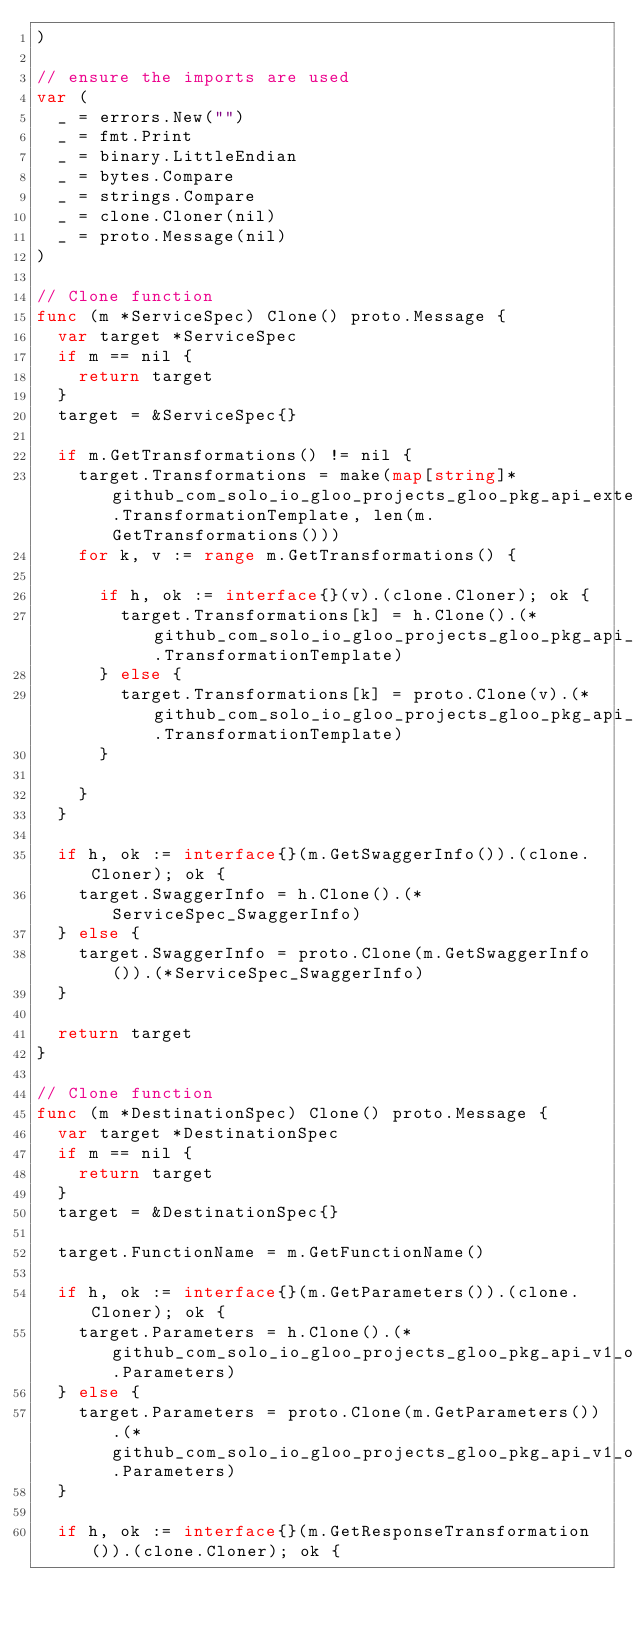<code> <loc_0><loc_0><loc_500><loc_500><_Go_>)

// ensure the imports are used
var (
	_ = errors.New("")
	_ = fmt.Print
	_ = binary.LittleEndian
	_ = bytes.Compare
	_ = strings.Compare
	_ = clone.Cloner(nil)
	_ = proto.Message(nil)
)

// Clone function
func (m *ServiceSpec) Clone() proto.Message {
	var target *ServiceSpec
	if m == nil {
		return target
	}
	target = &ServiceSpec{}

	if m.GetTransformations() != nil {
		target.Transformations = make(map[string]*github_com_solo_io_gloo_projects_gloo_pkg_api_external_envoy_extensions_transformation.TransformationTemplate, len(m.GetTransformations()))
		for k, v := range m.GetTransformations() {

			if h, ok := interface{}(v).(clone.Cloner); ok {
				target.Transformations[k] = h.Clone().(*github_com_solo_io_gloo_projects_gloo_pkg_api_external_envoy_extensions_transformation.TransformationTemplate)
			} else {
				target.Transformations[k] = proto.Clone(v).(*github_com_solo_io_gloo_projects_gloo_pkg_api_external_envoy_extensions_transformation.TransformationTemplate)
			}

		}
	}

	if h, ok := interface{}(m.GetSwaggerInfo()).(clone.Cloner); ok {
		target.SwaggerInfo = h.Clone().(*ServiceSpec_SwaggerInfo)
	} else {
		target.SwaggerInfo = proto.Clone(m.GetSwaggerInfo()).(*ServiceSpec_SwaggerInfo)
	}

	return target
}

// Clone function
func (m *DestinationSpec) Clone() proto.Message {
	var target *DestinationSpec
	if m == nil {
		return target
	}
	target = &DestinationSpec{}

	target.FunctionName = m.GetFunctionName()

	if h, ok := interface{}(m.GetParameters()).(clone.Cloner); ok {
		target.Parameters = h.Clone().(*github_com_solo_io_gloo_projects_gloo_pkg_api_v1_options_transformation.Parameters)
	} else {
		target.Parameters = proto.Clone(m.GetParameters()).(*github_com_solo_io_gloo_projects_gloo_pkg_api_v1_options_transformation.Parameters)
	}

	if h, ok := interface{}(m.GetResponseTransformation()).(clone.Cloner); ok {</code> 